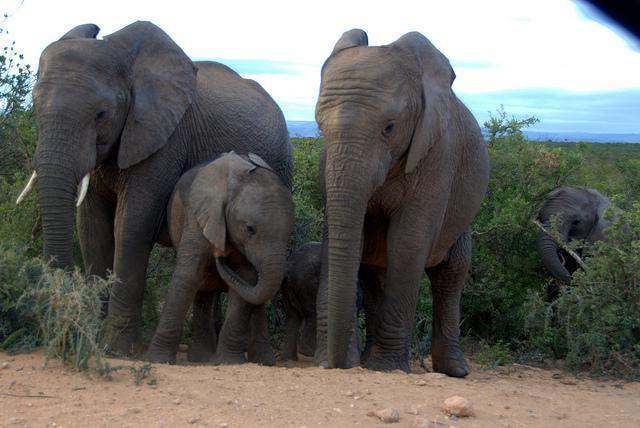How many animals are here?
Give a very brief answer. 4. How many elephants are visible?
Give a very brief answer. 5. 